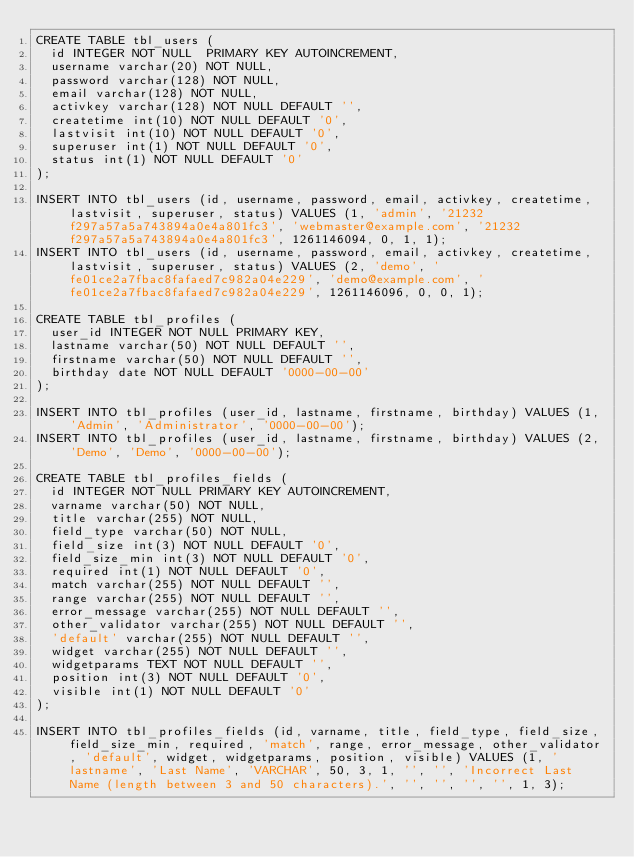<code> <loc_0><loc_0><loc_500><loc_500><_SQL_>CREATE TABLE tbl_users (
  id INTEGER NOT NULL  PRIMARY KEY AUTOINCREMENT,
  username varchar(20) NOT NULL,
  password varchar(128) NOT NULL,
  email varchar(128) NOT NULL,
  activkey varchar(128) NOT NULL DEFAULT '',
  createtime int(10) NOT NULL DEFAULT '0',
  lastvisit int(10) NOT NULL DEFAULT '0',
  superuser int(1) NOT NULL DEFAULT '0',
  status int(1) NOT NULL DEFAULT '0'
);

INSERT INTO tbl_users (id, username, password, email, activkey, createtime, lastvisit, superuser, status) VALUES (1, 'admin', '21232f297a57a5a743894a0e4a801fc3', 'webmaster@example.com', '21232f297a57a5a743894a0e4a801fc3', 1261146094, 0, 1, 1);
INSERT INTO tbl_users (id, username, password, email, activkey, createtime, lastvisit, superuser, status) VALUES (2, 'demo', 'fe01ce2a7fbac8fafaed7c982a04e229', 'demo@example.com', 'fe01ce2a7fbac8fafaed7c982a04e229', 1261146096, 0, 0, 1);

CREATE TABLE tbl_profiles (
  user_id INTEGER NOT NULL PRIMARY KEY,
  lastname varchar(50) NOT NULL DEFAULT '',
  firstname varchar(50) NOT NULL DEFAULT '',
  birthday date NOT NULL DEFAULT '0000-00-00'
);

INSERT INTO tbl_profiles (user_id, lastname, firstname, birthday) VALUES (1, 'Admin', 'Administrator', '0000-00-00');
INSERT INTO tbl_profiles (user_id, lastname, firstname, birthday) VALUES (2, 'Demo', 'Demo', '0000-00-00');

CREATE TABLE tbl_profiles_fields (
  id INTEGER NOT NULL PRIMARY KEY AUTOINCREMENT,
  varname varchar(50) NOT NULL,
  title varchar(255) NOT NULL,
  field_type varchar(50) NOT NULL,
  field_size int(3) NOT NULL DEFAULT '0',
  field_size_min int(3) NOT NULL DEFAULT '0',
  required int(1) NOT NULL DEFAULT '0',
  match varchar(255) NOT NULL DEFAULT '',
  range varchar(255) NOT NULL DEFAULT '',
  error_message varchar(255) NOT NULL DEFAULT '',
  other_validator varchar(255) NOT NULL DEFAULT '',
  'default' varchar(255) NOT NULL DEFAULT '',
  widget varchar(255) NOT NULL DEFAULT '',
  widgetparams TEXT NOT NULL DEFAULT '',
  position int(3) NOT NULL DEFAULT '0',
  visible int(1) NOT NULL DEFAULT '0'
);

INSERT INTO tbl_profiles_fields (id, varname, title, field_type, field_size, field_size_min, required, 'match', range, error_message, other_validator, 'default', widget, widgetparams, position, visible) VALUES (1, 'lastname', 'Last Name', 'VARCHAR', 50, 3, 1, '', '', 'Incorrect Last Name (length between 3 and 50 characters).', '', '', '', '', 1, 3);</code> 